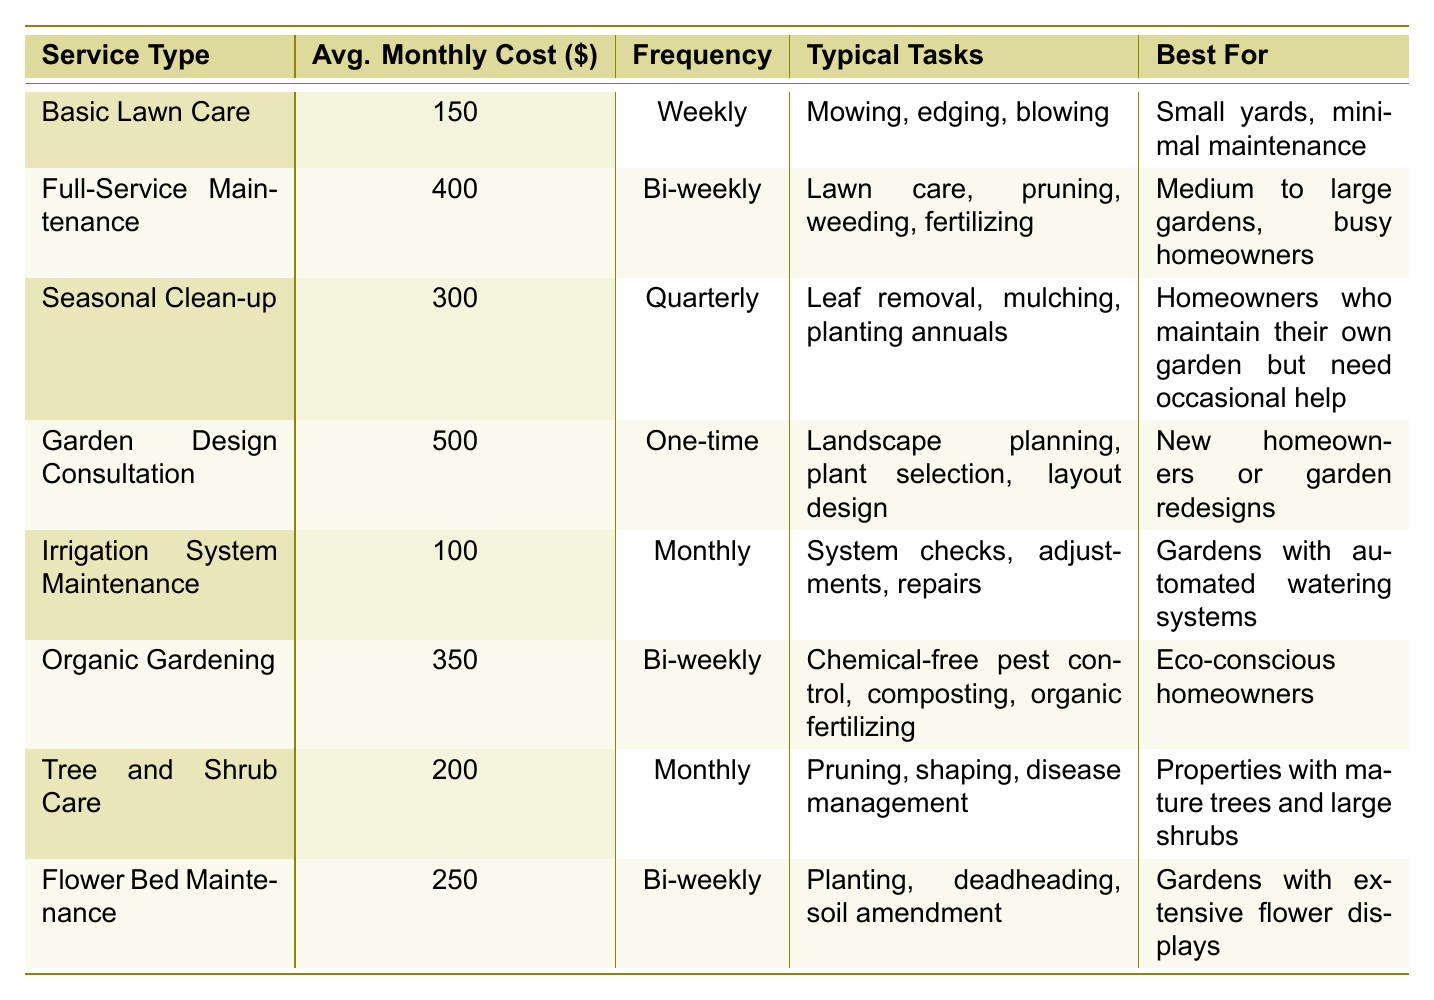What is the average monthly cost of Full-Service Maintenance? The table lists the average monthly cost for Full-Service Maintenance as $400.
Answer: 400 Which service type requires the most frequent maintenance? The Basic Lawn Care service appears weekly, making it the most frequent maintenance type.
Answer: Weekly Is the cost of Seasonal Clean-up higher or lower than Tree and Shrub Care? Seasonal Clean-up costs $300 while Tree and Shrub Care costs $200, so it is higher.
Answer: Higher How much more expensive is Organic Gardening compared to Irrigation System Maintenance? Organic Gardening costs $350 and Irrigation System Maintenance costs $100. The difference is $350 - $100 = $250.
Answer: 250 What is the total average monthly cost of all services listed? Adding all average monthly costs: 150 + 400 + 300 + 500 + 100 + 350 + 200 + 250 = 2250. Thus, the total average cost is $2250.
Answer: 2250 Which service type is best for eco-conscious homeowners? The table indicates Organic Gardening is the best choice for eco-conscious homeowners.
Answer: Organic Gardening If a homeowner uses Full-Service Maintenance and Flower Bed Maintenance, what is their combined average monthly cost? The costs are $400 for Full-Service Maintenance and $250 for Flower Bed Maintenance. Adding them gives $400 + $250 = $650.
Answer: 650 Are there any one-time service types in the table? Yes, the Garden Design Consultation is a one-time service type as noted in the frequency column.
Answer: Yes How many services are provided on a bi-weekly basis? There are three services listed with a bi-weekly frequency: Full-Service Maintenance, Organic Gardening, and Flower Bed Maintenance.
Answer: 3 Is the average monthly cost for Flower Bed Maintenance greater than that of Irrigation System Maintenance? Flower Bed Maintenance costs $250, while Irrigation System Maintenance costs $100, making it greater.
Answer: Yes 